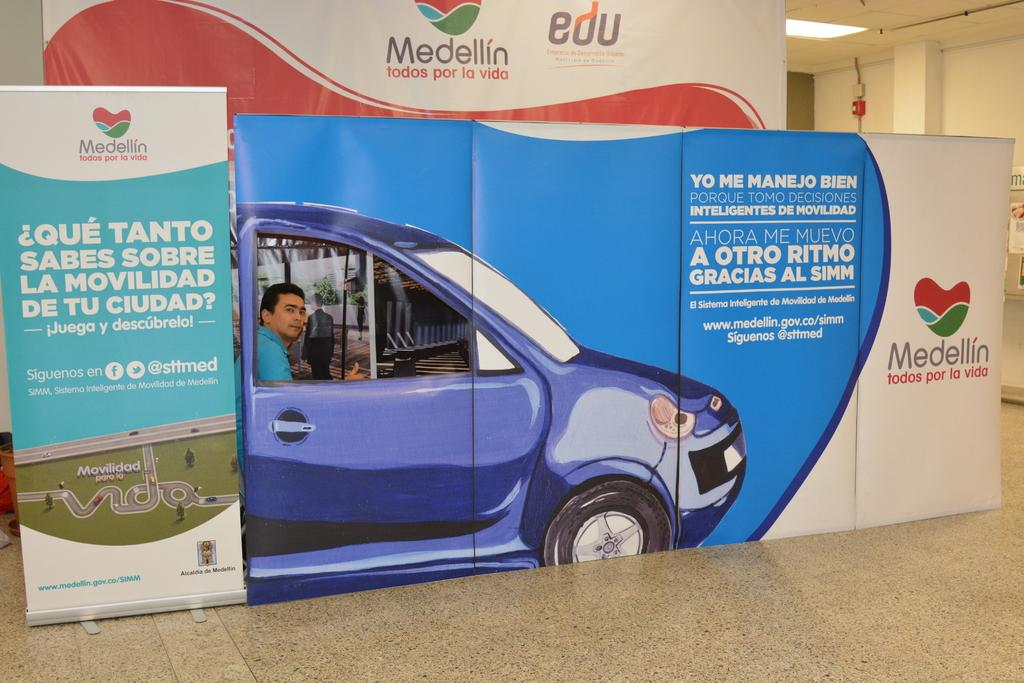What is written on the board in the image? There is written text on a board in the image. What can be seen under the board in the image? The floor is visible in the image. How many people are in the image? There is at least one person in the image. What is visible behind the person in the image? There is a wall in the background of the image. What is above the person in the image? The ceiling is visible in the image. What is attached to the ceiling in the image? There is a light on the ceiling. What type of event is being celebrated in the image? There is no indication of an event being celebrated in the image. 